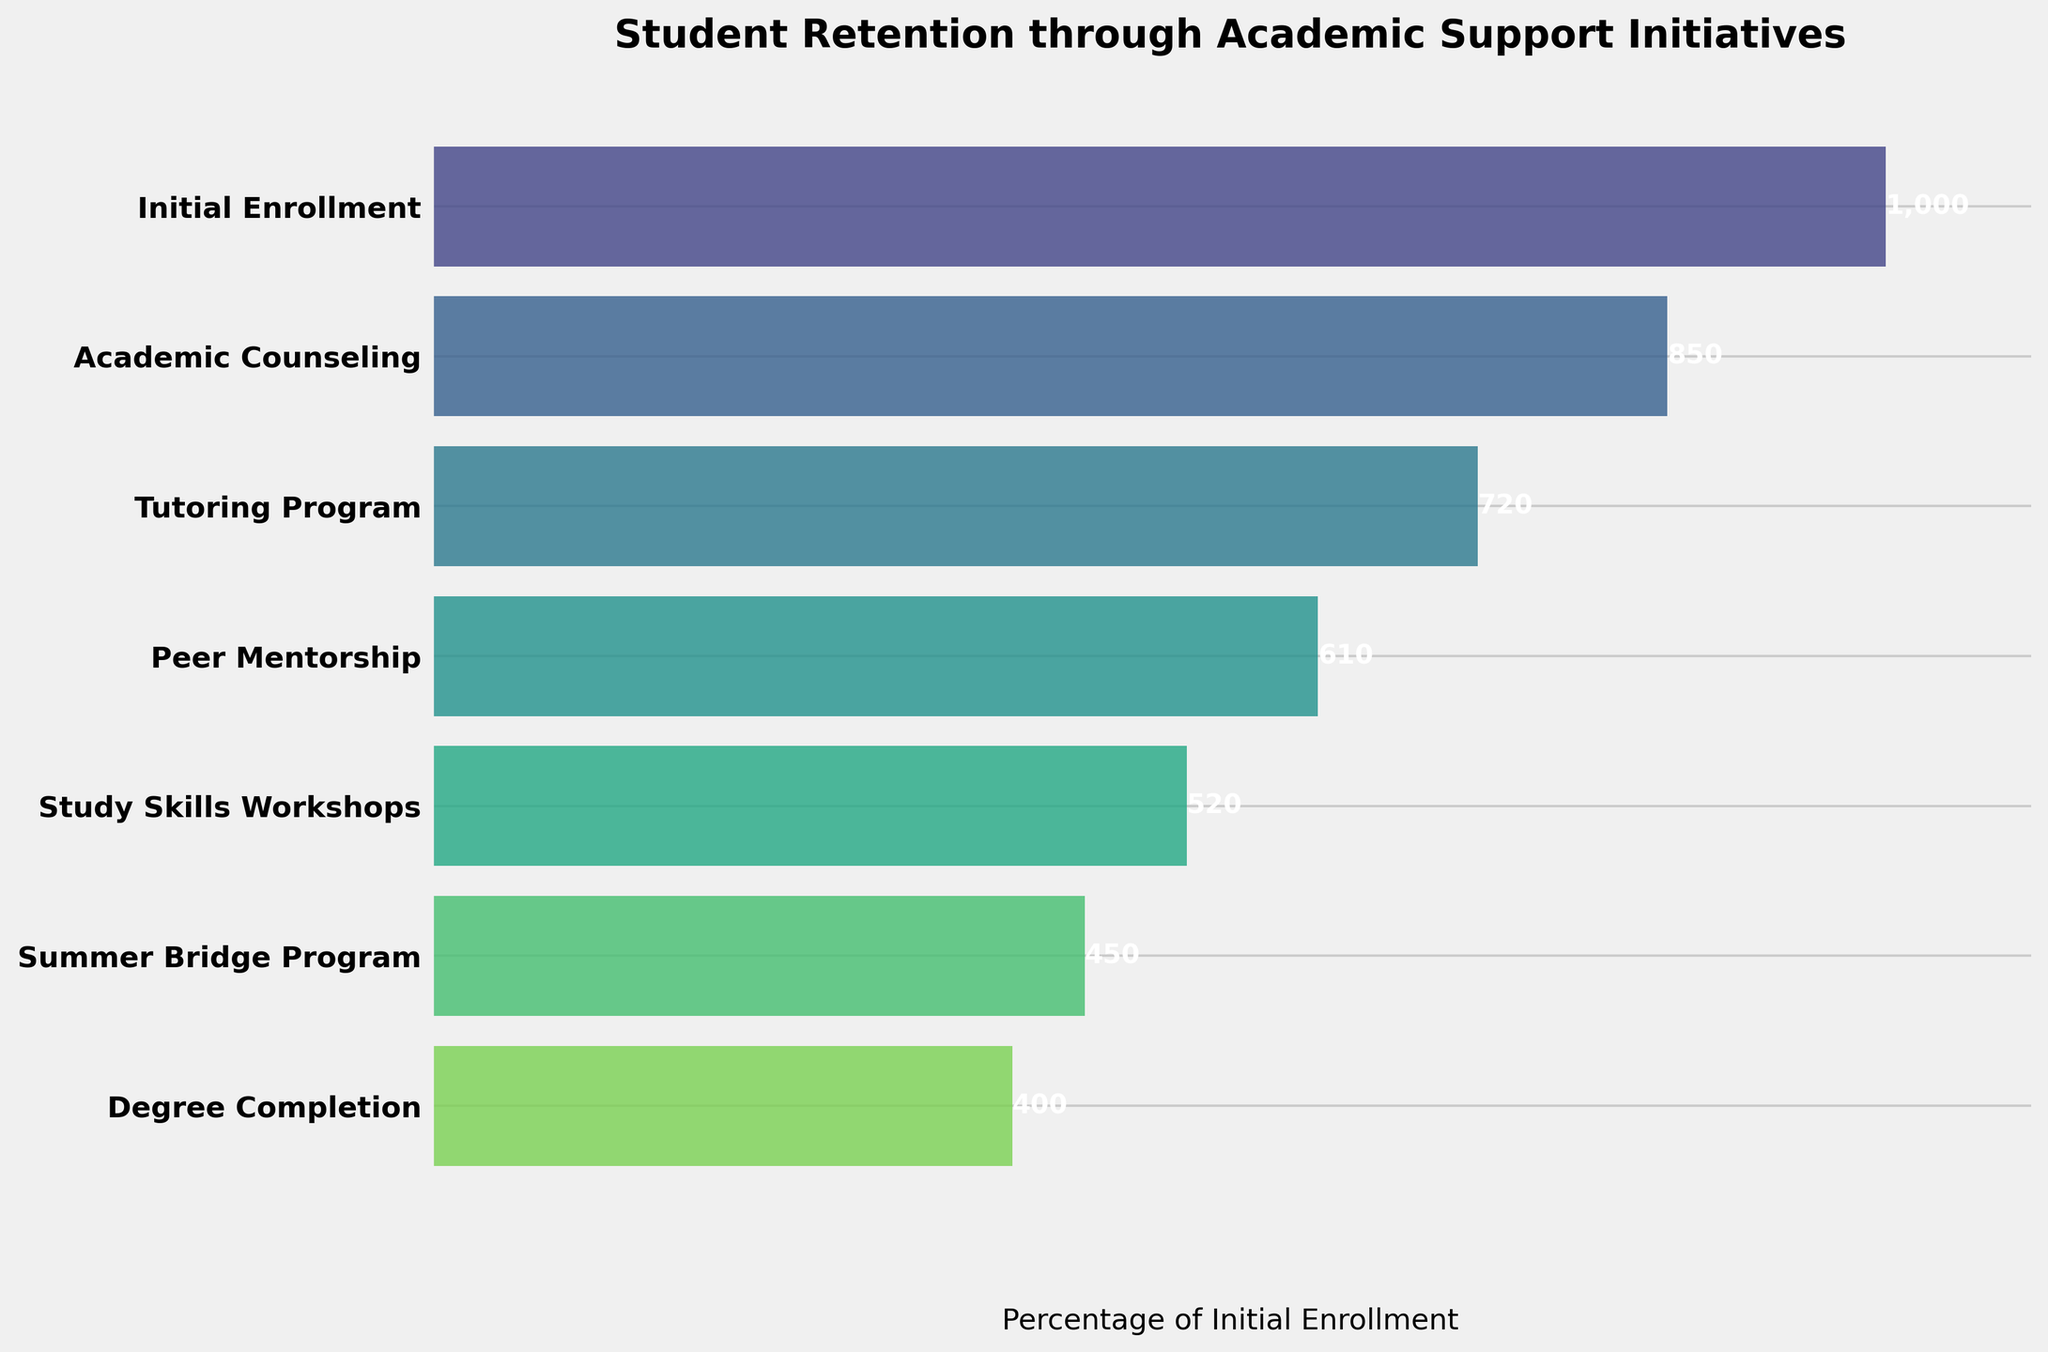What is the title of the funnel chart? The title of a plot is usually found at the top of the figure. In this case, it is "Student Retention through Academic Support Initiatives."
Answer: Student Retention through Academic Support Initiatives What is the value of the initial enrollment? The value for each stage is shown next to the respective bar. The initial enrollment value is found at the top of the chart.
Answer: 1,000 By how much does the number of students drop from the initial enrollment to academic counseling? The difference between the number of students in the initial enrollment and academic counseling is calculated by subtracting 850 (academic counseling) from 1,000 (initial enrollment).
Answer: 150 Which stage has the largest drop in the number of students? To find the stage with the largest drop, we compare the differences between consecutive stages. The largest decrease is between Academic Counseling (850) to Tutoring Program (720) or Study Skills Workshops (520) to Summer Bridge Program (450). Calculating the differences, 850 - 720 = 130 and 520 - 450 = 70, hence the largest drop is from Academic Counseling to Tutoring Program (130 students).
Answer: Academic Counseling to Tutoring Program How many total stages are displayed in the funnel chart? The number of stages can be counted by identifying each level in the funnel chart. There are seven stages listed in the figure.
Answer: 7 What percentage of students from the initial enrollment make it to degree completion? Calculate the percentage by dividing the number of students at degree completion (400) by the initial enrollment (1,000) and then multiply by 100. So, (400 / 1,000) * 100 = 40%.
Answer: 40% Which stage retains more students, Peer Mentorship or Study Skills Workshops? Compare the number of students in the Peer Mentorship stage (610) with those in the Study Skills Workshops stage (520). 610 is greater than 520.
Answer: Peer Mentorship Which stage has fewer students, Summer Bridge Program or Degree Completion? Compare the number of students in the Summer Bridge Program (450) with those in Degree Completion (400). 400 is less than 450.
Answer: Degree Completion What's the average number of students in academic support initiatives from Tutoring Program to Degree Completion? To find the average, add the number of students in the Tutoring Program (720), Peer Mentorship (610), Study Skills Workshops (520), Summer Bridge Program (450), and Degree Completion (400) stages, then divide by 5. So, (720 + 610 + 520 + 450 + 400) / 5 = 2,700 / 5 = 540.
Answer: 540 Explain the trend shown in the funnel chart. The trend indicates a gradual decrease in the number of students as they progress through each stage of the academic support initiatives. The largest drop is observed from the Academic Counseling stage to the Tutoring Program stage, and the retention gradually decreases until the Degree Completion stage.
Answer: Decreasing trend in student retention as they progress through stages 